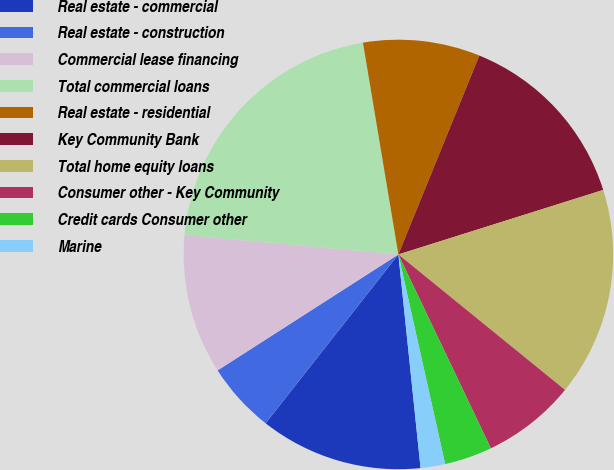Convert chart. <chart><loc_0><loc_0><loc_500><loc_500><pie_chart><fcel>Real estate - commercial<fcel>Real estate - construction<fcel>Commercial lease financing<fcel>Total commercial loans<fcel>Real estate - residential<fcel>Key Community Bank<fcel>Total home equity loans<fcel>Consumer other - Key Community<fcel>Credit cards Consumer other<fcel>Marine<nl><fcel>12.25%<fcel>5.32%<fcel>10.52%<fcel>20.92%<fcel>8.79%<fcel>13.99%<fcel>15.72%<fcel>7.05%<fcel>3.59%<fcel>1.85%<nl></chart> 